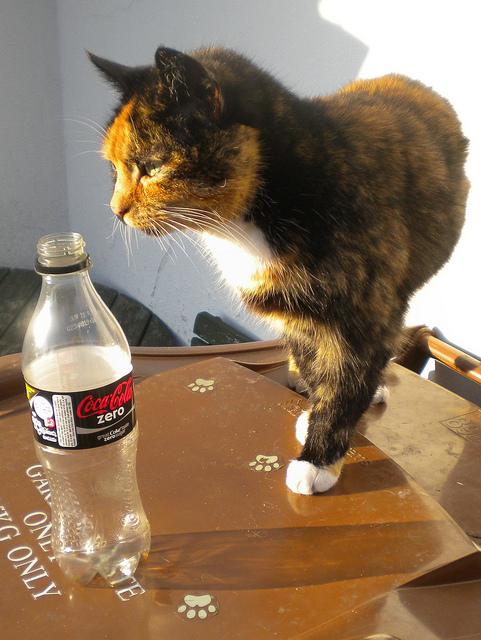What brand of soda is this?
Short answer required. Coca cola. Is the bottle empty?
Concise answer only. Yes. Did the cat make the paw prints on the sign?
Short answer required. No. 